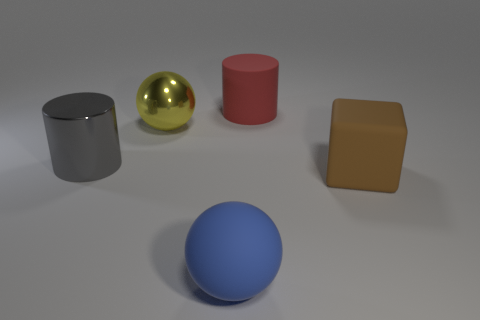Add 1 tiny red metal cylinders. How many objects exist? 6 Subtract all balls. How many objects are left? 3 Add 4 large brown objects. How many large brown objects are left? 5 Add 3 large gray shiny cubes. How many large gray shiny cubes exist? 3 Subtract 0 cyan cylinders. How many objects are left? 5 Subtract all small purple metallic objects. Subtract all big metal objects. How many objects are left? 3 